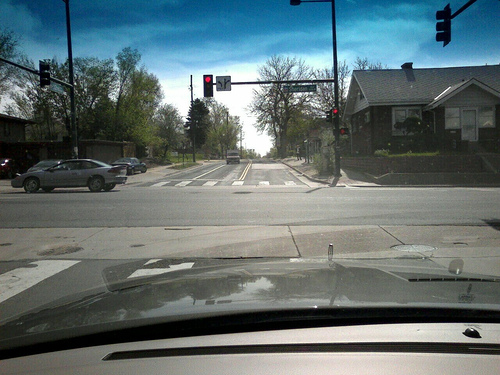Can you describe the crosswalk situation? The crosswalk is clearly marked with white lines for pedestrians to cross safely. There are also pedestrian signal lights above to indicate when it's safe to walk across. 